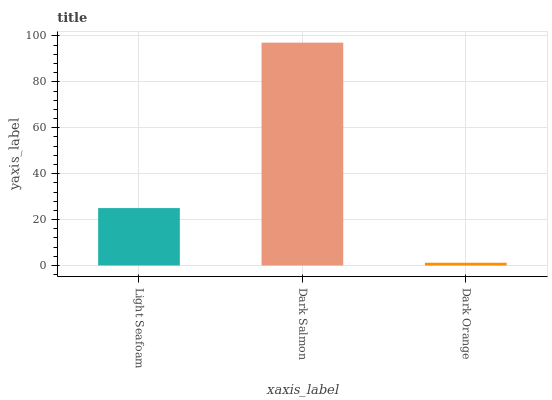Is Dark Orange the minimum?
Answer yes or no. Yes. Is Dark Salmon the maximum?
Answer yes or no. Yes. Is Dark Salmon the minimum?
Answer yes or no. No. Is Dark Orange the maximum?
Answer yes or no. No. Is Dark Salmon greater than Dark Orange?
Answer yes or no. Yes. Is Dark Orange less than Dark Salmon?
Answer yes or no. Yes. Is Dark Orange greater than Dark Salmon?
Answer yes or no. No. Is Dark Salmon less than Dark Orange?
Answer yes or no. No. Is Light Seafoam the high median?
Answer yes or no. Yes. Is Light Seafoam the low median?
Answer yes or no. Yes. Is Dark Orange the high median?
Answer yes or no. No. Is Dark Orange the low median?
Answer yes or no. No. 